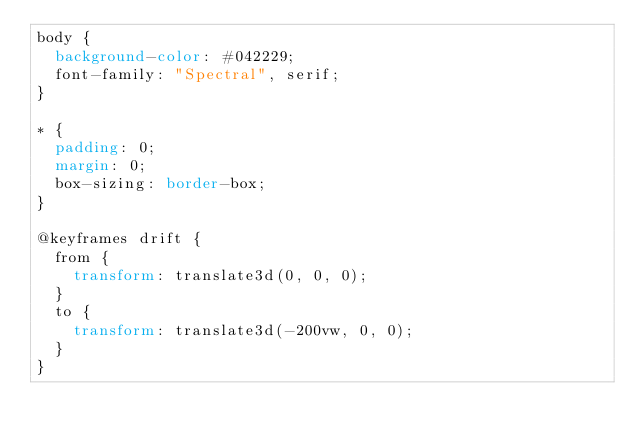<code> <loc_0><loc_0><loc_500><loc_500><_CSS_>body {
  background-color: #042229;
  font-family: "Spectral", serif;
}

* {
  padding: 0;
  margin: 0;
  box-sizing: border-box;
}

@keyframes drift {
  from {
    transform: translate3d(0, 0, 0);
  }
  to {
    transform: translate3d(-200vw, 0, 0);
  }
}
</code> 